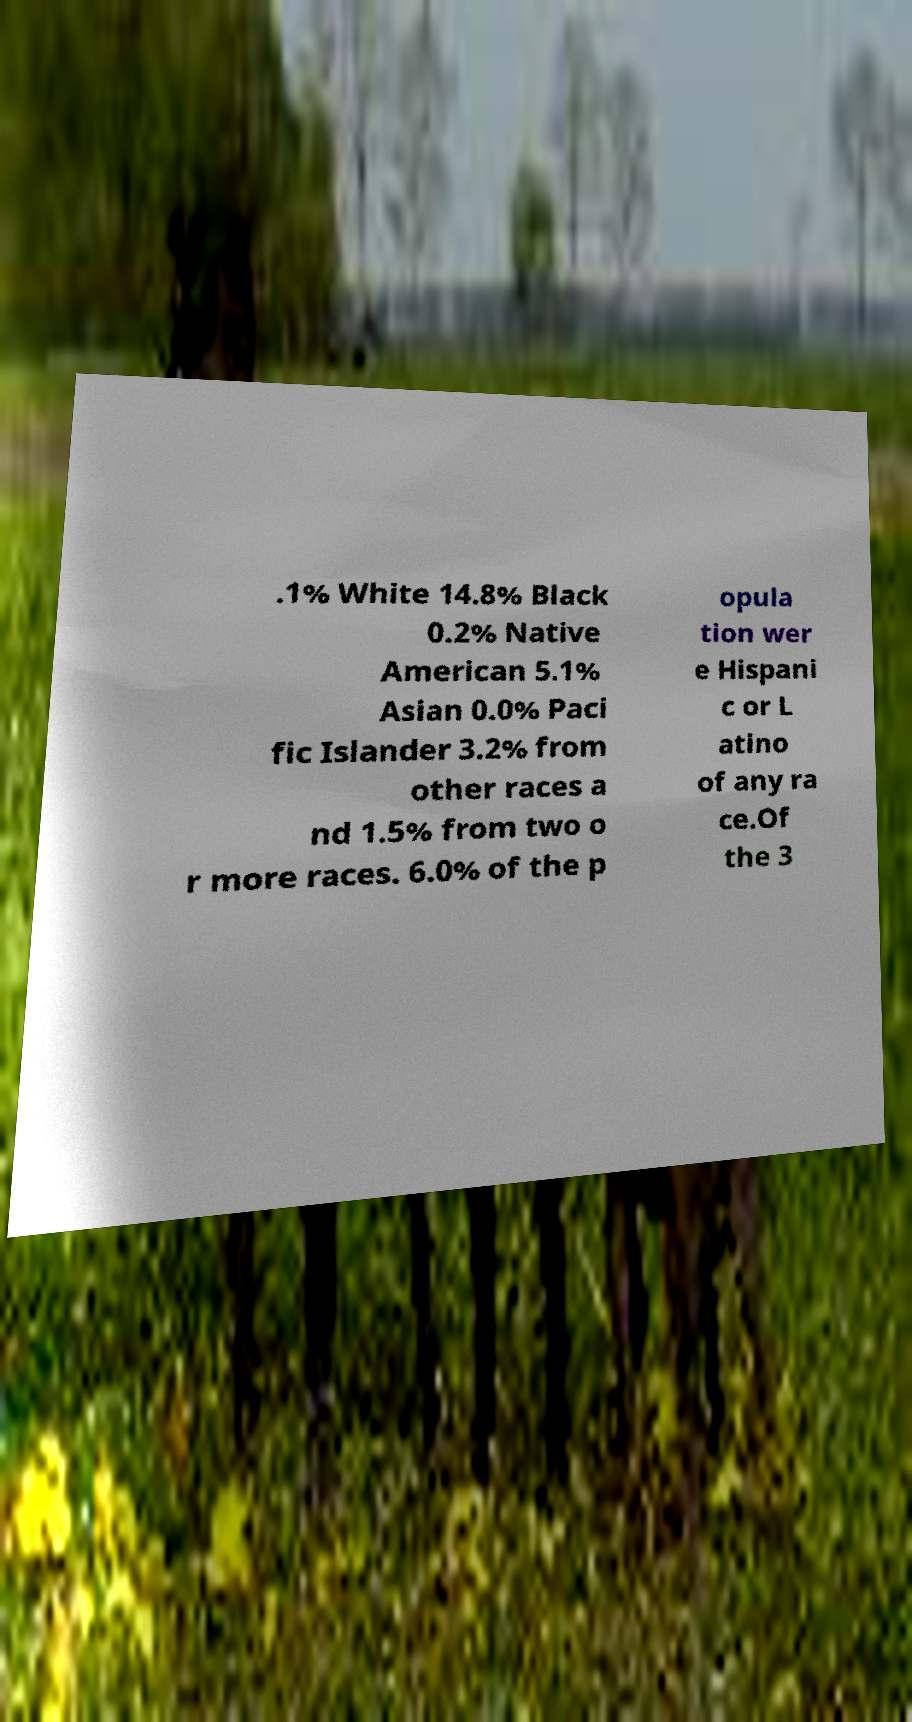I need the written content from this picture converted into text. Can you do that? .1% White 14.8% Black 0.2% Native American 5.1% Asian 0.0% Paci fic Islander 3.2% from other races a nd 1.5% from two o r more races. 6.0% of the p opula tion wer e Hispani c or L atino of any ra ce.Of the 3 